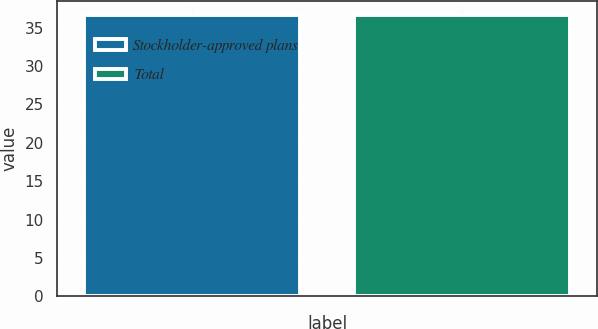Convert chart to OTSL. <chart><loc_0><loc_0><loc_500><loc_500><bar_chart><fcel>Stockholder-approved plans<fcel>Total<nl><fcel>36.61<fcel>36.71<nl></chart> 